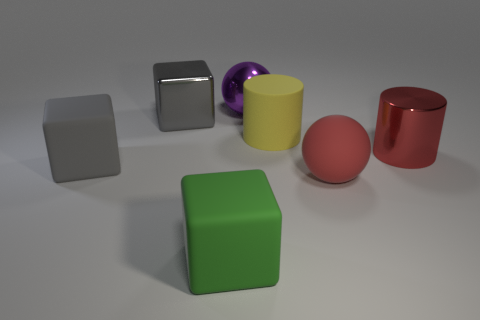Which objects in the image could possibly fit together as a lid and container based on their shapes and sizes? The red cylindrical object and the yellow cylindrical object have shapes that suggest they could function as a container with a lid, assuming the dimensions are appropriate for one to fit over the other. 